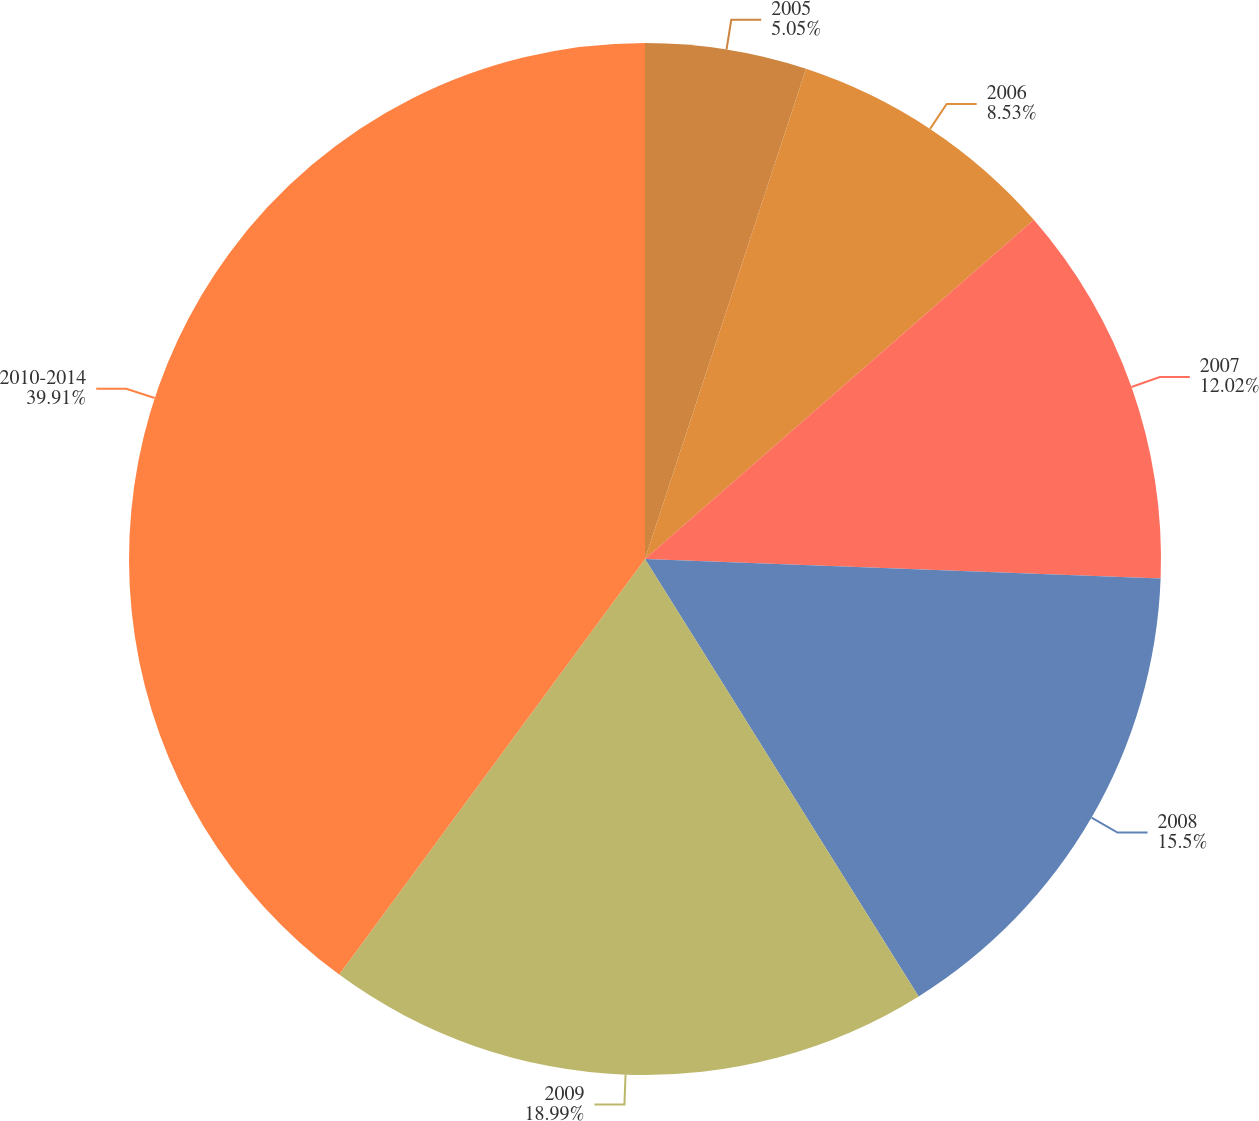Convert chart to OTSL. <chart><loc_0><loc_0><loc_500><loc_500><pie_chart><fcel>2005<fcel>2006<fcel>2007<fcel>2008<fcel>2009<fcel>2010-2014<nl><fcel>5.05%<fcel>8.53%<fcel>12.02%<fcel>15.5%<fcel>18.99%<fcel>39.9%<nl></chart> 